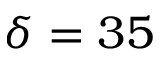<formula> <loc_0><loc_0><loc_500><loc_500>\delta = 3 5</formula> 